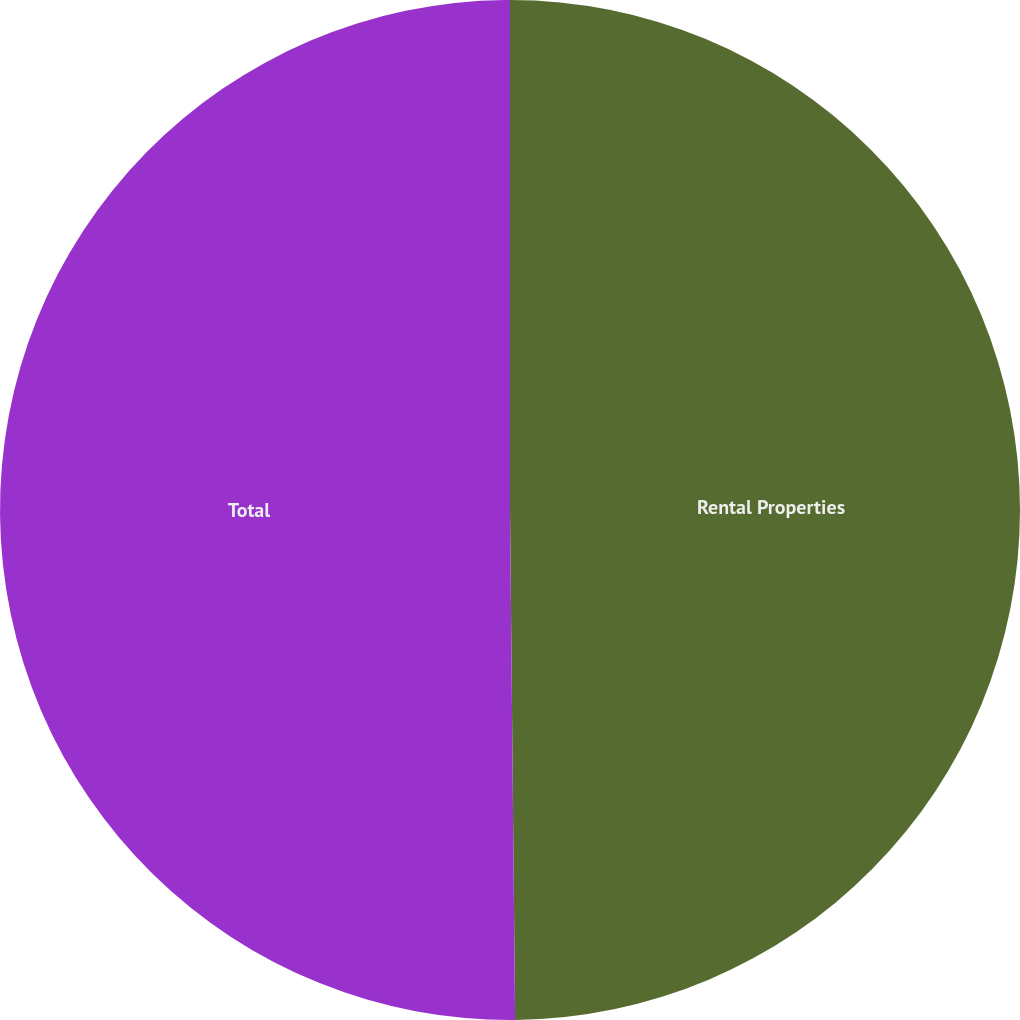<chart> <loc_0><loc_0><loc_500><loc_500><pie_chart><fcel>Rental Properties<fcel>Total<nl><fcel>49.84%<fcel>50.16%<nl></chart> 